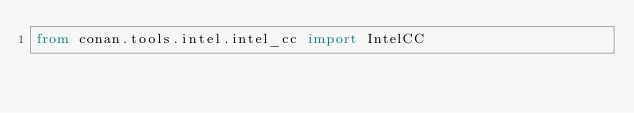Convert code to text. <code><loc_0><loc_0><loc_500><loc_500><_Python_>from conan.tools.intel.intel_cc import IntelCC
</code> 